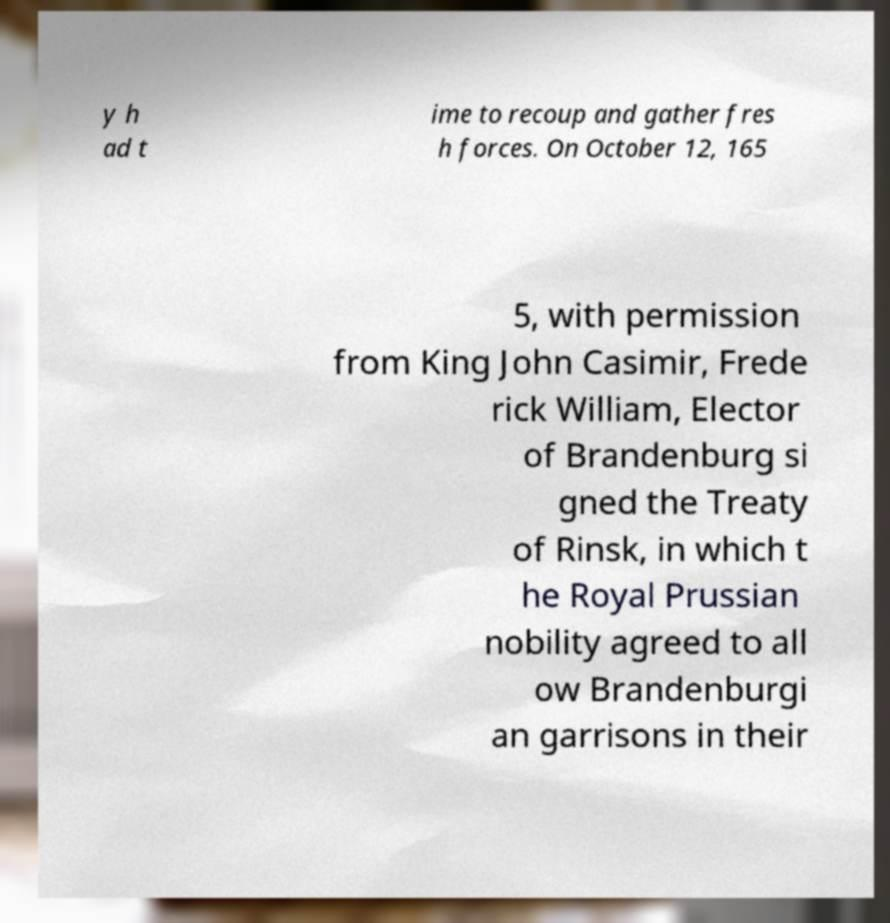Could you assist in decoding the text presented in this image and type it out clearly? y h ad t ime to recoup and gather fres h forces. On October 12, 165 5, with permission from King John Casimir, Frede rick William, Elector of Brandenburg si gned the Treaty of Rinsk, in which t he Royal Prussian nobility agreed to all ow Brandenburgi an garrisons in their 